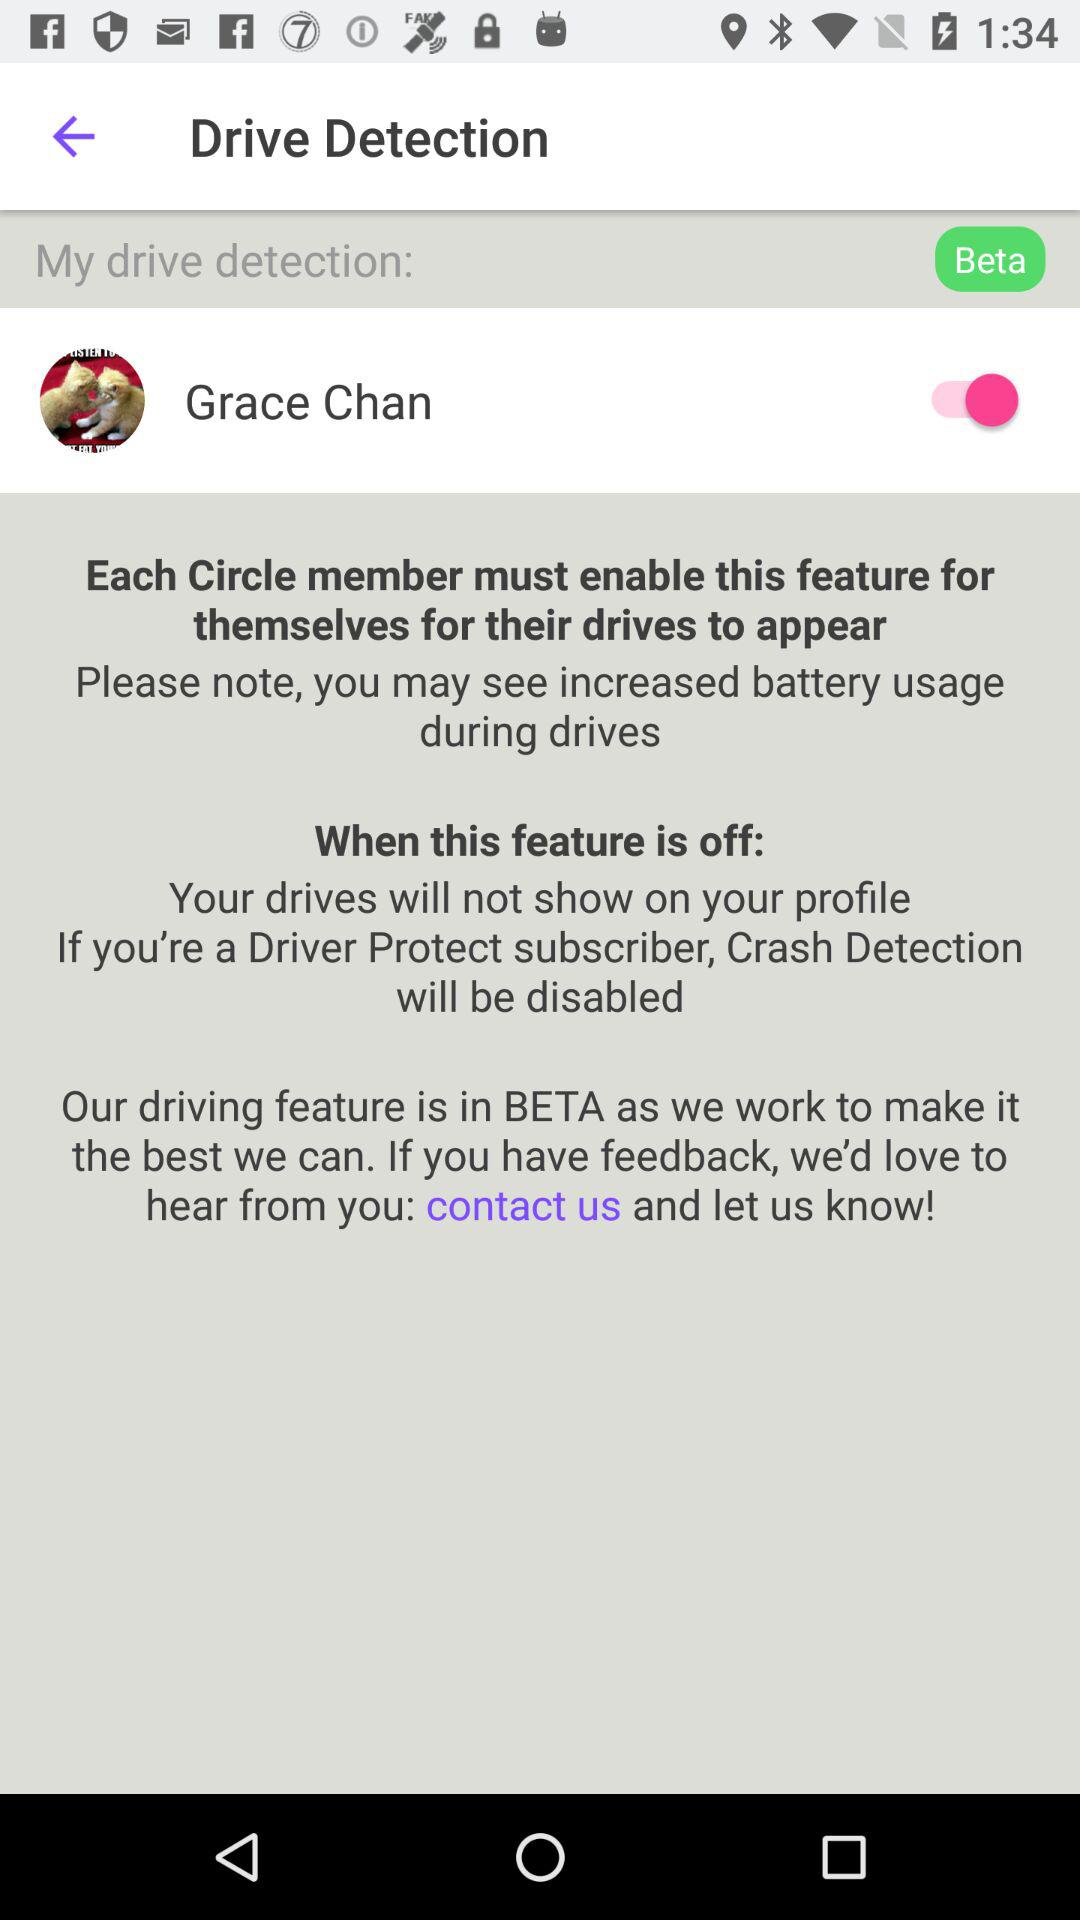What is the name of the user? The name of the user is "Grace Chan". 